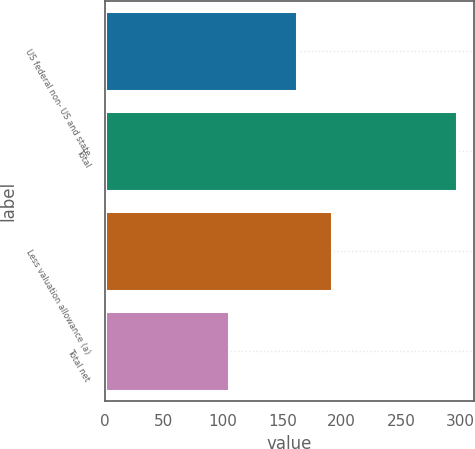<chart> <loc_0><loc_0><loc_500><loc_500><bar_chart><fcel>US federal non- US and state<fcel>Total<fcel>Less valuation allowance (a)<fcel>Total net<nl><fcel>162<fcel>297<fcel>192<fcel>105<nl></chart> 